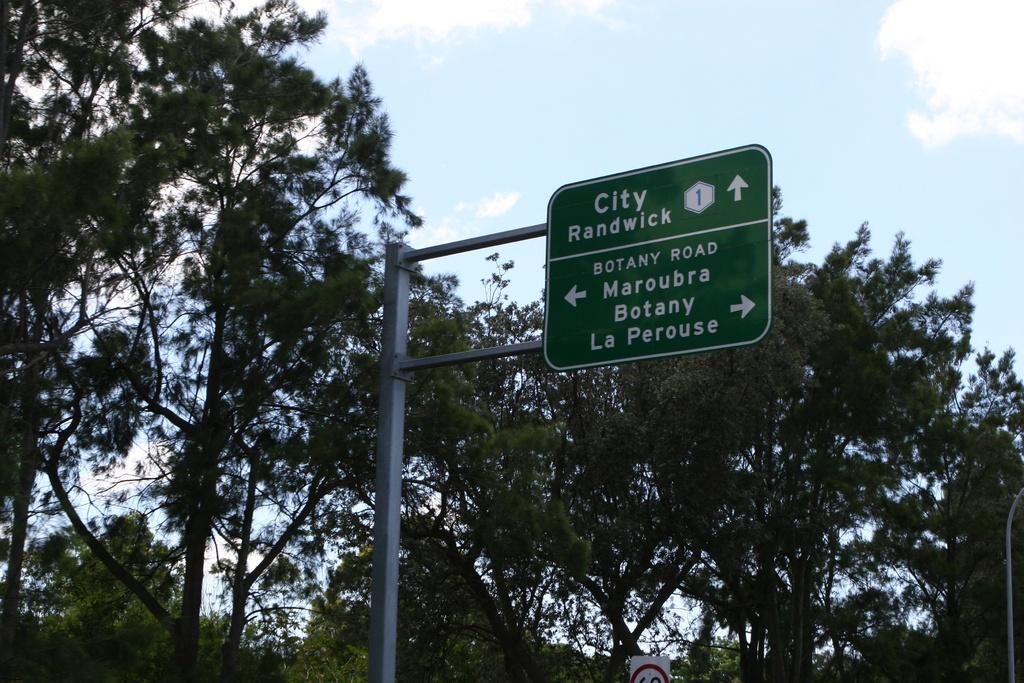What is attached to the pole in the image? There is a board attached to a pole in the image. What is the color of the board? The board is green in color. What can be seen in the background of the image? There are trees in the background of the image. What is the color of the trees? The trees are green in color. What is visible above the trees in the image? The sky is visible in the image. What colors can be seen in the sky? The sky has a combination of white and blue colors. Where is the girl standing in the image? There is no girl present in the image. Which direction is the north located in the image? The image does not provide any information about the direction of north. How many sheep are visible in the image? There are no sheep present in the image. 